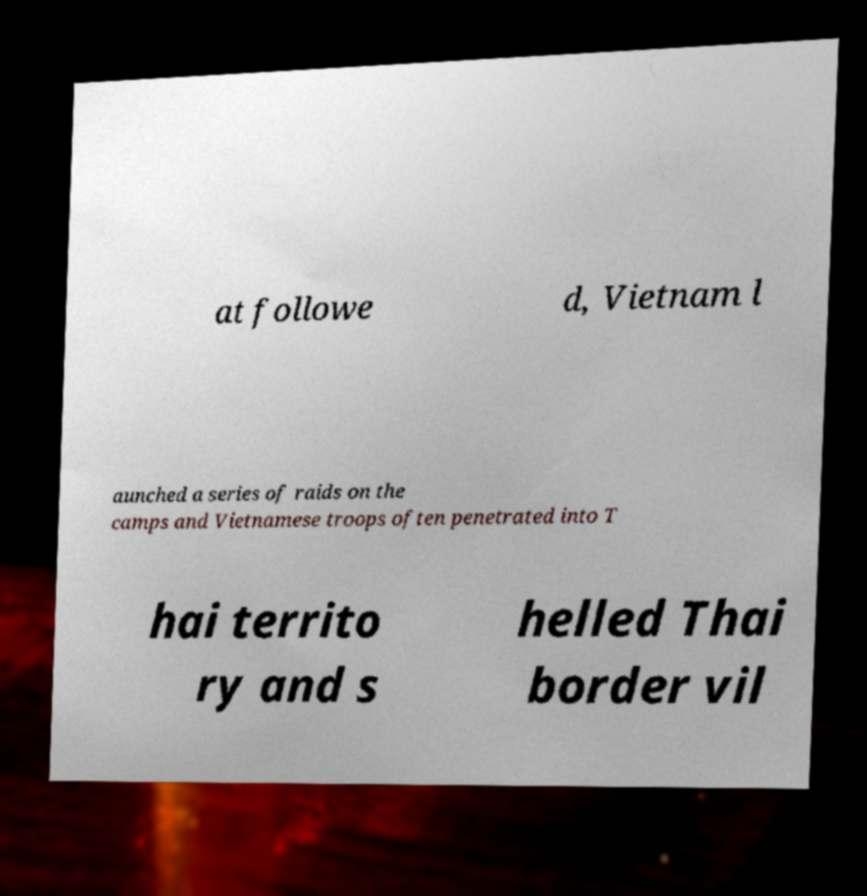I need the written content from this picture converted into text. Can you do that? at followe d, Vietnam l aunched a series of raids on the camps and Vietnamese troops often penetrated into T hai territo ry and s helled Thai border vil 